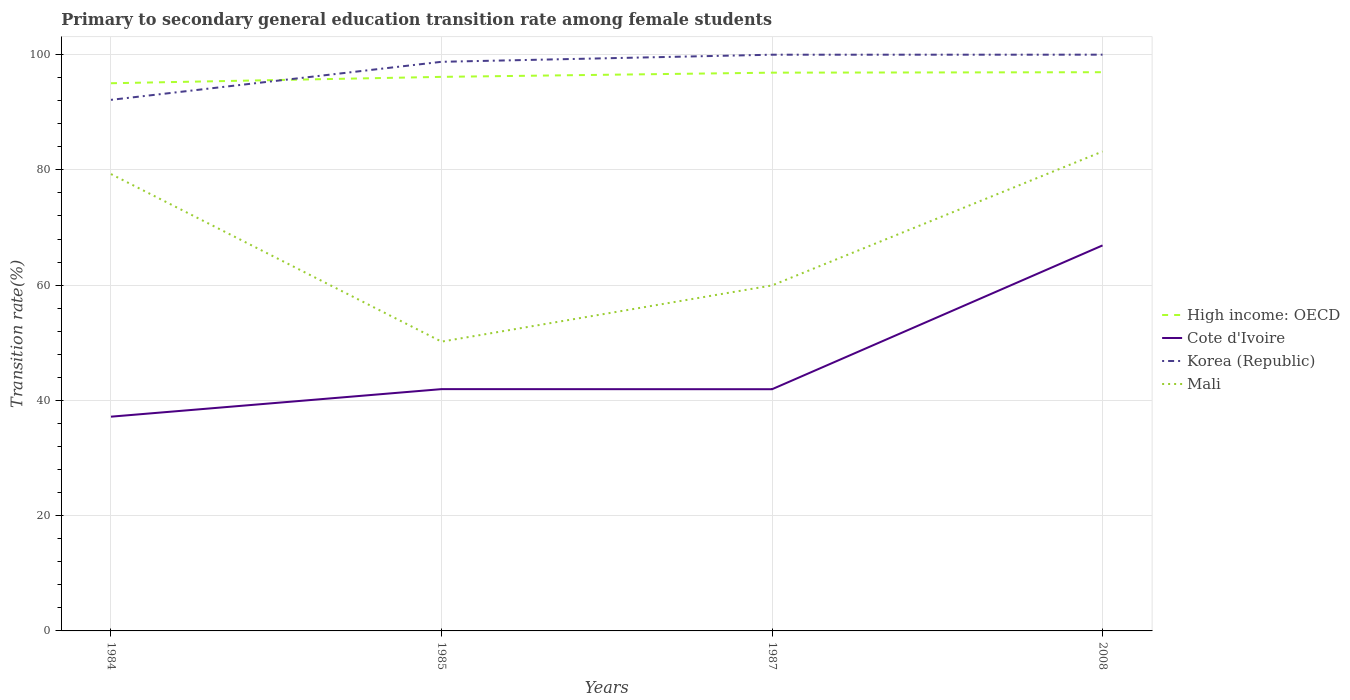How many different coloured lines are there?
Offer a very short reply. 4. Across all years, what is the maximum transition rate in Cote d'Ivoire?
Offer a very short reply. 37.17. What is the total transition rate in High income: OECD in the graph?
Offer a very short reply. -0.81. What is the difference between the highest and the second highest transition rate in Cote d'Ivoire?
Your response must be concise. 29.72. What is the difference between the highest and the lowest transition rate in Korea (Republic)?
Keep it short and to the point. 3. Is the transition rate in Korea (Republic) strictly greater than the transition rate in Cote d'Ivoire over the years?
Make the answer very short. No. How many lines are there?
Your answer should be compact. 4. What is the difference between two consecutive major ticks on the Y-axis?
Your response must be concise. 20. Are the values on the major ticks of Y-axis written in scientific E-notation?
Ensure brevity in your answer.  No. How are the legend labels stacked?
Make the answer very short. Vertical. What is the title of the graph?
Offer a terse response. Primary to secondary general education transition rate among female students. Does "Djibouti" appear as one of the legend labels in the graph?
Ensure brevity in your answer.  No. What is the label or title of the X-axis?
Provide a short and direct response. Years. What is the label or title of the Y-axis?
Make the answer very short. Transition rate(%). What is the Transition rate(%) of High income: OECD in 1984?
Your answer should be very brief. 95.03. What is the Transition rate(%) of Cote d'Ivoire in 1984?
Offer a terse response. 37.17. What is the Transition rate(%) of Korea (Republic) in 1984?
Offer a terse response. 92.15. What is the Transition rate(%) in Mali in 1984?
Provide a short and direct response. 79.27. What is the Transition rate(%) of High income: OECD in 1985?
Offer a terse response. 96.13. What is the Transition rate(%) of Cote d'Ivoire in 1985?
Provide a short and direct response. 41.95. What is the Transition rate(%) of Korea (Republic) in 1985?
Your response must be concise. 98.75. What is the Transition rate(%) in Mali in 1985?
Offer a very short reply. 50.2. What is the Transition rate(%) in High income: OECD in 1987?
Offer a terse response. 96.86. What is the Transition rate(%) in Cote d'Ivoire in 1987?
Provide a short and direct response. 41.94. What is the Transition rate(%) of Korea (Republic) in 1987?
Offer a terse response. 99.98. What is the Transition rate(%) of Mali in 1987?
Your answer should be compact. 59.95. What is the Transition rate(%) in High income: OECD in 2008?
Offer a terse response. 96.94. What is the Transition rate(%) of Cote d'Ivoire in 2008?
Keep it short and to the point. 66.89. What is the Transition rate(%) of Korea (Republic) in 2008?
Provide a short and direct response. 99.98. What is the Transition rate(%) of Mali in 2008?
Your response must be concise. 83.19. Across all years, what is the maximum Transition rate(%) in High income: OECD?
Keep it short and to the point. 96.94. Across all years, what is the maximum Transition rate(%) in Cote d'Ivoire?
Offer a very short reply. 66.89. Across all years, what is the maximum Transition rate(%) of Korea (Republic)?
Provide a succinct answer. 99.98. Across all years, what is the maximum Transition rate(%) in Mali?
Ensure brevity in your answer.  83.19. Across all years, what is the minimum Transition rate(%) of High income: OECD?
Your answer should be very brief. 95.03. Across all years, what is the minimum Transition rate(%) in Cote d'Ivoire?
Keep it short and to the point. 37.17. Across all years, what is the minimum Transition rate(%) in Korea (Republic)?
Provide a short and direct response. 92.15. Across all years, what is the minimum Transition rate(%) in Mali?
Offer a very short reply. 50.2. What is the total Transition rate(%) of High income: OECD in the graph?
Make the answer very short. 384.97. What is the total Transition rate(%) in Cote d'Ivoire in the graph?
Make the answer very short. 187.96. What is the total Transition rate(%) in Korea (Republic) in the graph?
Keep it short and to the point. 390.86. What is the total Transition rate(%) of Mali in the graph?
Give a very brief answer. 272.6. What is the difference between the Transition rate(%) in High income: OECD in 1984 and that in 1985?
Your answer should be compact. -1.11. What is the difference between the Transition rate(%) in Cote d'Ivoire in 1984 and that in 1985?
Make the answer very short. -4.78. What is the difference between the Transition rate(%) in Korea (Republic) in 1984 and that in 1985?
Your answer should be very brief. -6.6. What is the difference between the Transition rate(%) in Mali in 1984 and that in 1985?
Offer a very short reply. 29.08. What is the difference between the Transition rate(%) in High income: OECD in 1984 and that in 1987?
Ensure brevity in your answer.  -1.84. What is the difference between the Transition rate(%) in Cote d'Ivoire in 1984 and that in 1987?
Offer a very short reply. -4.76. What is the difference between the Transition rate(%) in Korea (Republic) in 1984 and that in 1987?
Provide a succinct answer. -7.83. What is the difference between the Transition rate(%) in Mali in 1984 and that in 1987?
Keep it short and to the point. 19.33. What is the difference between the Transition rate(%) of High income: OECD in 1984 and that in 2008?
Your response must be concise. -1.91. What is the difference between the Transition rate(%) in Cote d'Ivoire in 1984 and that in 2008?
Make the answer very short. -29.72. What is the difference between the Transition rate(%) of Korea (Republic) in 1984 and that in 2008?
Give a very brief answer. -7.84. What is the difference between the Transition rate(%) in Mali in 1984 and that in 2008?
Your response must be concise. -3.91. What is the difference between the Transition rate(%) of High income: OECD in 1985 and that in 1987?
Provide a short and direct response. -0.73. What is the difference between the Transition rate(%) of Cote d'Ivoire in 1985 and that in 1987?
Provide a short and direct response. 0.02. What is the difference between the Transition rate(%) of Korea (Republic) in 1985 and that in 1987?
Your answer should be compact. -1.23. What is the difference between the Transition rate(%) in Mali in 1985 and that in 1987?
Your answer should be compact. -9.75. What is the difference between the Transition rate(%) of High income: OECD in 1985 and that in 2008?
Your answer should be compact. -0.81. What is the difference between the Transition rate(%) of Cote d'Ivoire in 1985 and that in 2008?
Make the answer very short. -24.94. What is the difference between the Transition rate(%) in Korea (Republic) in 1985 and that in 2008?
Provide a short and direct response. -1.24. What is the difference between the Transition rate(%) in Mali in 1985 and that in 2008?
Your response must be concise. -32.99. What is the difference between the Transition rate(%) in High income: OECD in 1987 and that in 2008?
Offer a terse response. -0.08. What is the difference between the Transition rate(%) of Cote d'Ivoire in 1987 and that in 2008?
Offer a very short reply. -24.95. What is the difference between the Transition rate(%) of Korea (Republic) in 1987 and that in 2008?
Provide a succinct answer. -0.01. What is the difference between the Transition rate(%) in Mali in 1987 and that in 2008?
Your answer should be compact. -23.24. What is the difference between the Transition rate(%) of High income: OECD in 1984 and the Transition rate(%) of Cote d'Ivoire in 1985?
Your answer should be very brief. 53.07. What is the difference between the Transition rate(%) of High income: OECD in 1984 and the Transition rate(%) of Korea (Republic) in 1985?
Make the answer very short. -3.72. What is the difference between the Transition rate(%) in High income: OECD in 1984 and the Transition rate(%) in Mali in 1985?
Make the answer very short. 44.83. What is the difference between the Transition rate(%) in Cote d'Ivoire in 1984 and the Transition rate(%) in Korea (Republic) in 1985?
Your answer should be compact. -61.57. What is the difference between the Transition rate(%) of Cote d'Ivoire in 1984 and the Transition rate(%) of Mali in 1985?
Provide a short and direct response. -13.02. What is the difference between the Transition rate(%) of Korea (Republic) in 1984 and the Transition rate(%) of Mali in 1985?
Keep it short and to the point. 41.95. What is the difference between the Transition rate(%) of High income: OECD in 1984 and the Transition rate(%) of Cote d'Ivoire in 1987?
Give a very brief answer. 53.09. What is the difference between the Transition rate(%) in High income: OECD in 1984 and the Transition rate(%) in Korea (Republic) in 1987?
Offer a very short reply. -4.95. What is the difference between the Transition rate(%) of High income: OECD in 1984 and the Transition rate(%) of Mali in 1987?
Offer a very short reply. 35.08. What is the difference between the Transition rate(%) in Cote d'Ivoire in 1984 and the Transition rate(%) in Korea (Republic) in 1987?
Keep it short and to the point. -62.81. What is the difference between the Transition rate(%) in Cote d'Ivoire in 1984 and the Transition rate(%) in Mali in 1987?
Your answer should be very brief. -22.77. What is the difference between the Transition rate(%) of Korea (Republic) in 1984 and the Transition rate(%) of Mali in 1987?
Give a very brief answer. 32.2. What is the difference between the Transition rate(%) in High income: OECD in 1984 and the Transition rate(%) in Cote d'Ivoire in 2008?
Your answer should be very brief. 28.14. What is the difference between the Transition rate(%) of High income: OECD in 1984 and the Transition rate(%) of Korea (Republic) in 2008?
Make the answer very short. -4.96. What is the difference between the Transition rate(%) in High income: OECD in 1984 and the Transition rate(%) in Mali in 2008?
Offer a very short reply. 11.84. What is the difference between the Transition rate(%) in Cote d'Ivoire in 1984 and the Transition rate(%) in Korea (Republic) in 2008?
Provide a short and direct response. -62.81. What is the difference between the Transition rate(%) of Cote d'Ivoire in 1984 and the Transition rate(%) of Mali in 2008?
Provide a succinct answer. -46.01. What is the difference between the Transition rate(%) in Korea (Republic) in 1984 and the Transition rate(%) in Mali in 2008?
Provide a short and direct response. 8.96. What is the difference between the Transition rate(%) of High income: OECD in 1985 and the Transition rate(%) of Cote d'Ivoire in 1987?
Provide a succinct answer. 54.2. What is the difference between the Transition rate(%) of High income: OECD in 1985 and the Transition rate(%) of Korea (Republic) in 1987?
Your response must be concise. -3.85. What is the difference between the Transition rate(%) in High income: OECD in 1985 and the Transition rate(%) in Mali in 1987?
Keep it short and to the point. 36.19. What is the difference between the Transition rate(%) of Cote d'Ivoire in 1985 and the Transition rate(%) of Korea (Republic) in 1987?
Give a very brief answer. -58.02. What is the difference between the Transition rate(%) of Cote d'Ivoire in 1985 and the Transition rate(%) of Mali in 1987?
Give a very brief answer. -17.99. What is the difference between the Transition rate(%) of Korea (Republic) in 1985 and the Transition rate(%) of Mali in 1987?
Offer a very short reply. 38.8. What is the difference between the Transition rate(%) of High income: OECD in 1985 and the Transition rate(%) of Cote d'Ivoire in 2008?
Your answer should be compact. 29.24. What is the difference between the Transition rate(%) of High income: OECD in 1985 and the Transition rate(%) of Korea (Republic) in 2008?
Provide a short and direct response. -3.85. What is the difference between the Transition rate(%) in High income: OECD in 1985 and the Transition rate(%) in Mali in 2008?
Provide a succinct answer. 12.95. What is the difference between the Transition rate(%) of Cote d'Ivoire in 1985 and the Transition rate(%) of Korea (Republic) in 2008?
Keep it short and to the point. -58.03. What is the difference between the Transition rate(%) of Cote d'Ivoire in 1985 and the Transition rate(%) of Mali in 2008?
Provide a short and direct response. -41.23. What is the difference between the Transition rate(%) of Korea (Republic) in 1985 and the Transition rate(%) of Mali in 2008?
Your response must be concise. 15.56. What is the difference between the Transition rate(%) in High income: OECD in 1987 and the Transition rate(%) in Cote d'Ivoire in 2008?
Ensure brevity in your answer.  29.97. What is the difference between the Transition rate(%) in High income: OECD in 1987 and the Transition rate(%) in Korea (Republic) in 2008?
Your response must be concise. -3.12. What is the difference between the Transition rate(%) in High income: OECD in 1987 and the Transition rate(%) in Mali in 2008?
Offer a very short reply. 13.68. What is the difference between the Transition rate(%) in Cote d'Ivoire in 1987 and the Transition rate(%) in Korea (Republic) in 2008?
Offer a very short reply. -58.05. What is the difference between the Transition rate(%) in Cote d'Ivoire in 1987 and the Transition rate(%) in Mali in 2008?
Keep it short and to the point. -41.25. What is the difference between the Transition rate(%) in Korea (Republic) in 1987 and the Transition rate(%) in Mali in 2008?
Provide a short and direct response. 16.79. What is the average Transition rate(%) of High income: OECD per year?
Make the answer very short. 96.24. What is the average Transition rate(%) of Cote d'Ivoire per year?
Offer a very short reply. 46.99. What is the average Transition rate(%) of Korea (Republic) per year?
Ensure brevity in your answer.  97.71. What is the average Transition rate(%) of Mali per year?
Make the answer very short. 68.15. In the year 1984, what is the difference between the Transition rate(%) in High income: OECD and Transition rate(%) in Cote d'Ivoire?
Make the answer very short. 57.85. In the year 1984, what is the difference between the Transition rate(%) of High income: OECD and Transition rate(%) of Korea (Republic)?
Give a very brief answer. 2.88. In the year 1984, what is the difference between the Transition rate(%) of High income: OECD and Transition rate(%) of Mali?
Your answer should be compact. 15.76. In the year 1984, what is the difference between the Transition rate(%) of Cote d'Ivoire and Transition rate(%) of Korea (Republic)?
Give a very brief answer. -54.97. In the year 1984, what is the difference between the Transition rate(%) in Cote d'Ivoire and Transition rate(%) in Mali?
Provide a succinct answer. -42.1. In the year 1984, what is the difference between the Transition rate(%) in Korea (Republic) and Transition rate(%) in Mali?
Provide a succinct answer. 12.87. In the year 1985, what is the difference between the Transition rate(%) of High income: OECD and Transition rate(%) of Cote d'Ivoire?
Your answer should be compact. 54.18. In the year 1985, what is the difference between the Transition rate(%) of High income: OECD and Transition rate(%) of Korea (Republic)?
Your response must be concise. -2.61. In the year 1985, what is the difference between the Transition rate(%) of High income: OECD and Transition rate(%) of Mali?
Make the answer very short. 45.94. In the year 1985, what is the difference between the Transition rate(%) of Cote d'Ivoire and Transition rate(%) of Korea (Republic)?
Offer a terse response. -56.79. In the year 1985, what is the difference between the Transition rate(%) in Cote d'Ivoire and Transition rate(%) in Mali?
Your response must be concise. -8.24. In the year 1985, what is the difference between the Transition rate(%) of Korea (Republic) and Transition rate(%) of Mali?
Give a very brief answer. 48.55. In the year 1987, what is the difference between the Transition rate(%) of High income: OECD and Transition rate(%) of Cote d'Ivoire?
Your answer should be compact. 54.93. In the year 1987, what is the difference between the Transition rate(%) in High income: OECD and Transition rate(%) in Korea (Republic)?
Provide a succinct answer. -3.12. In the year 1987, what is the difference between the Transition rate(%) of High income: OECD and Transition rate(%) of Mali?
Your response must be concise. 36.92. In the year 1987, what is the difference between the Transition rate(%) of Cote d'Ivoire and Transition rate(%) of Korea (Republic)?
Your response must be concise. -58.04. In the year 1987, what is the difference between the Transition rate(%) of Cote d'Ivoire and Transition rate(%) of Mali?
Your answer should be compact. -18.01. In the year 1987, what is the difference between the Transition rate(%) in Korea (Republic) and Transition rate(%) in Mali?
Provide a short and direct response. 40.03. In the year 2008, what is the difference between the Transition rate(%) in High income: OECD and Transition rate(%) in Cote d'Ivoire?
Your answer should be very brief. 30.05. In the year 2008, what is the difference between the Transition rate(%) in High income: OECD and Transition rate(%) in Korea (Republic)?
Make the answer very short. -3.04. In the year 2008, what is the difference between the Transition rate(%) of High income: OECD and Transition rate(%) of Mali?
Ensure brevity in your answer.  13.76. In the year 2008, what is the difference between the Transition rate(%) in Cote d'Ivoire and Transition rate(%) in Korea (Republic)?
Provide a succinct answer. -33.09. In the year 2008, what is the difference between the Transition rate(%) of Cote d'Ivoire and Transition rate(%) of Mali?
Provide a succinct answer. -16.3. In the year 2008, what is the difference between the Transition rate(%) of Korea (Republic) and Transition rate(%) of Mali?
Give a very brief answer. 16.8. What is the ratio of the Transition rate(%) in High income: OECD in 1984 to that in 1985?
Provide a succinct answer. 0.99. What is the ratio of the Transition rate(%) of Cote d'Ivoire in 1984 to that in 1985?
Offer a terse response. 0.89. What is the ratio of the Transition rate(%) in Korea (Republic) in 1984 to that in 1985?
Ensure brevity in your answer.  0.93. What is the ratio of the Transition rate(%) in Mali in 1984 to that in 1985?
Provide a short and direct response. 1.58. What is the ratio of the Transition rate(%) in Cote d'Ivoire in 1984 to that in 1987?
Make the answer very short. 0.89. What is the ratio of the Transition rate(%) of Korea (Republic) in 1984 to that in 1987?
Provide a succinct answer. 0.92. What is the ratio of the Transition rate(%) of Mali in 1984 to that in 1987?
Offer a terse response. 1.32. What is the ratio of the Transition rate(%) of High income: OECD in 1984 to that in 2008?
Provide a short and direct response. 0.98. What is the ratio of the Transition rate(%) of Cote d'Ivoire in 1984 to that in 2008?
Your answer should be very brief. 0.56. What is the ratio of the Transition rate(%) of Korea (Republic) in 1984 to that in 2008?
Make the answer very short. 0.92. What is the ratio of the Transition rate(%) of Mali in 1984 to that in 2008?
Keep it short and to the point. 0.95. What is the ratio of the Transition rate(%) in Cote d'Ivoire in 1985 to that in 1987?
Ensure brevity in your answer.  1. What is the ratio of the Transition rate(%) of Korea (Republic) in 1985 to that in 1987?
Provide a succinct answer. 0.99. What is the ratio of the Transition rate(%) in Mali in 1985 to that in 1987?
Provide a succinct answer. 0.84. What is the ratio of the Transition rate(%) of Cote d'Ivoire in 1985 to that in 2008?
Keep it short and to the point. 0.63. What is the ratio of the Transition rate(%) in Korea (Republic) in 1985 to that in 2008?
Provide a succinct answer. 0.99. What is the ratio of the Transition rate(%) in Mali in 1985 to that in 2008?
Make the answer very short. 0.6. What is the ratio of the Transition rate(%) of Cote d'Ivoire in 1987 to that in 2008?
Offer a very short reply. 0.63. What is the ratio of the Transition rate(%) of Mali in 1987 to that in 2008?
Keep it short and to the point. 0.72. What is the difference between the highest and the second highest Transition rate(%) in High income: OECD?
Ensure brevity in your answer.  0.08. What is the difference between the highest and the second highest Transition rate(%) of Cote d'Ivoire?
Offer a terse response. 24.94. What is the difference between the highest and the second highest Transition rate(%) of Korea (Republic)?
Keep it short and to the point. 0.01. What is the difference between the highest and the second highest Transition rate(%) of Mali?
Ensure brevity in your answer.  3.91. What is the difference between the highest and the lowest Transition rate(%) in High income: OECD?
Give a very brief answer. 1.91. What is the difference between the highest and the lowest Transition rate(%) of Cote d'Ivoire?
Provide a short and direct response. 29.72. What is the difference between the highest and the lowest Transition rate(%) of Korea (Republic)?
Give a very brief answer. 7.84. What is the difference between the highest and the lowest Transition rate(%) of Mali?
Provide a succinct answer. 32.99. 